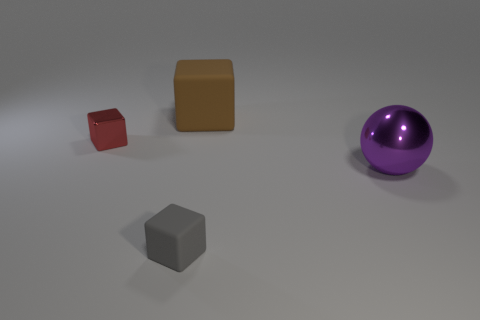Add 3 small metallic cubes. How many objects exist? 7 Subtract all balls. How many objects are left? 3 Add 3 blue rubber cylinders. How many blue rubber cylinders exist? 3 Subtract 0 blue blocks. How many objects are left? 4 Subtract all large purple shiny things. Subtract all tiny cubes. How many objects are left? 1 Add 3 tiny things. How many tiny things are left? 5 